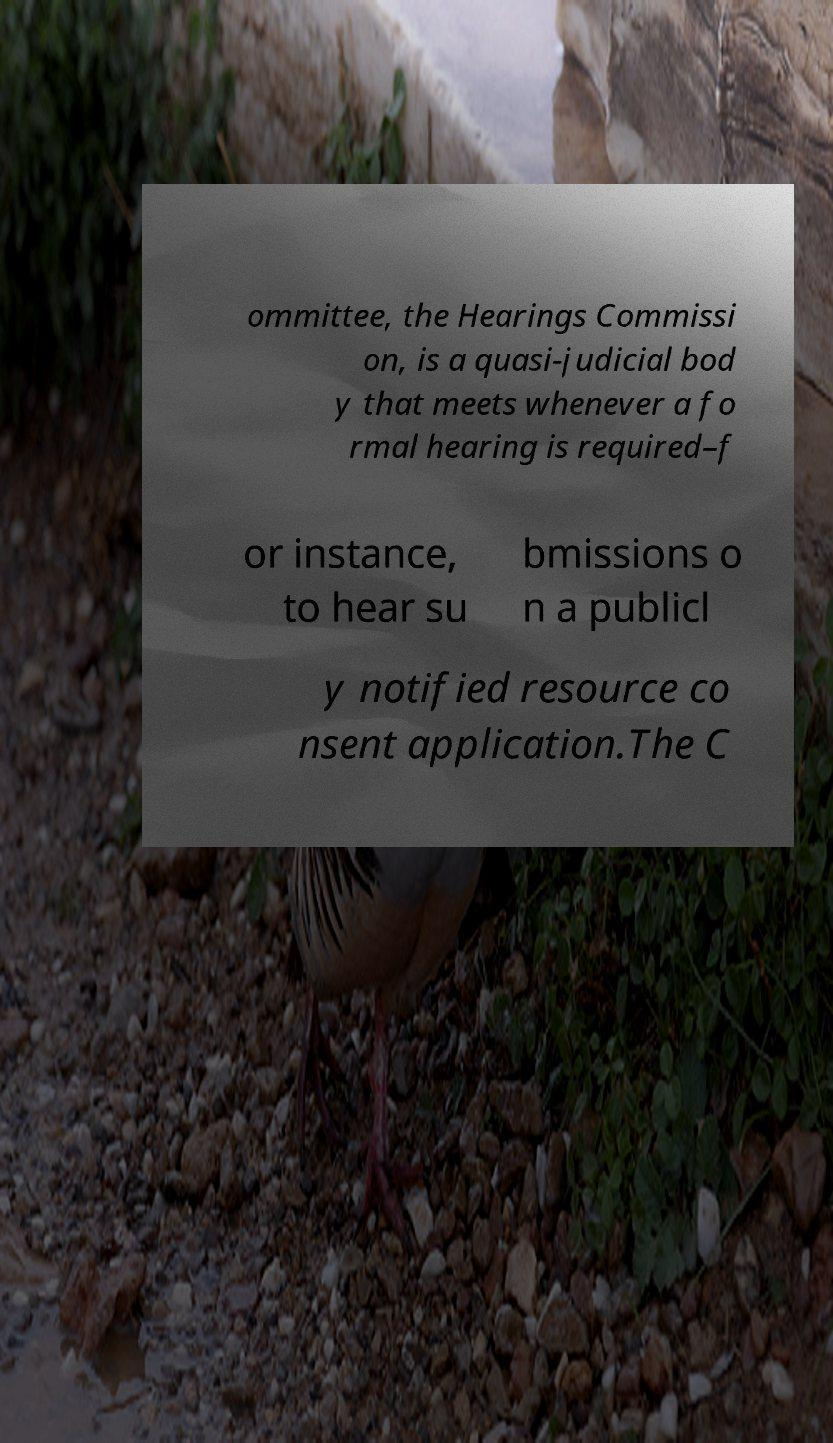Please read and relay the text visible in this image. What does it say? ommittee, the Hearings Commissi on, is a quasi-judicial bod y that meets whenever a fo rmal hearing is required–f or instance, to hear su bmissions o n a publicl y notified resource co nsent application.The C 